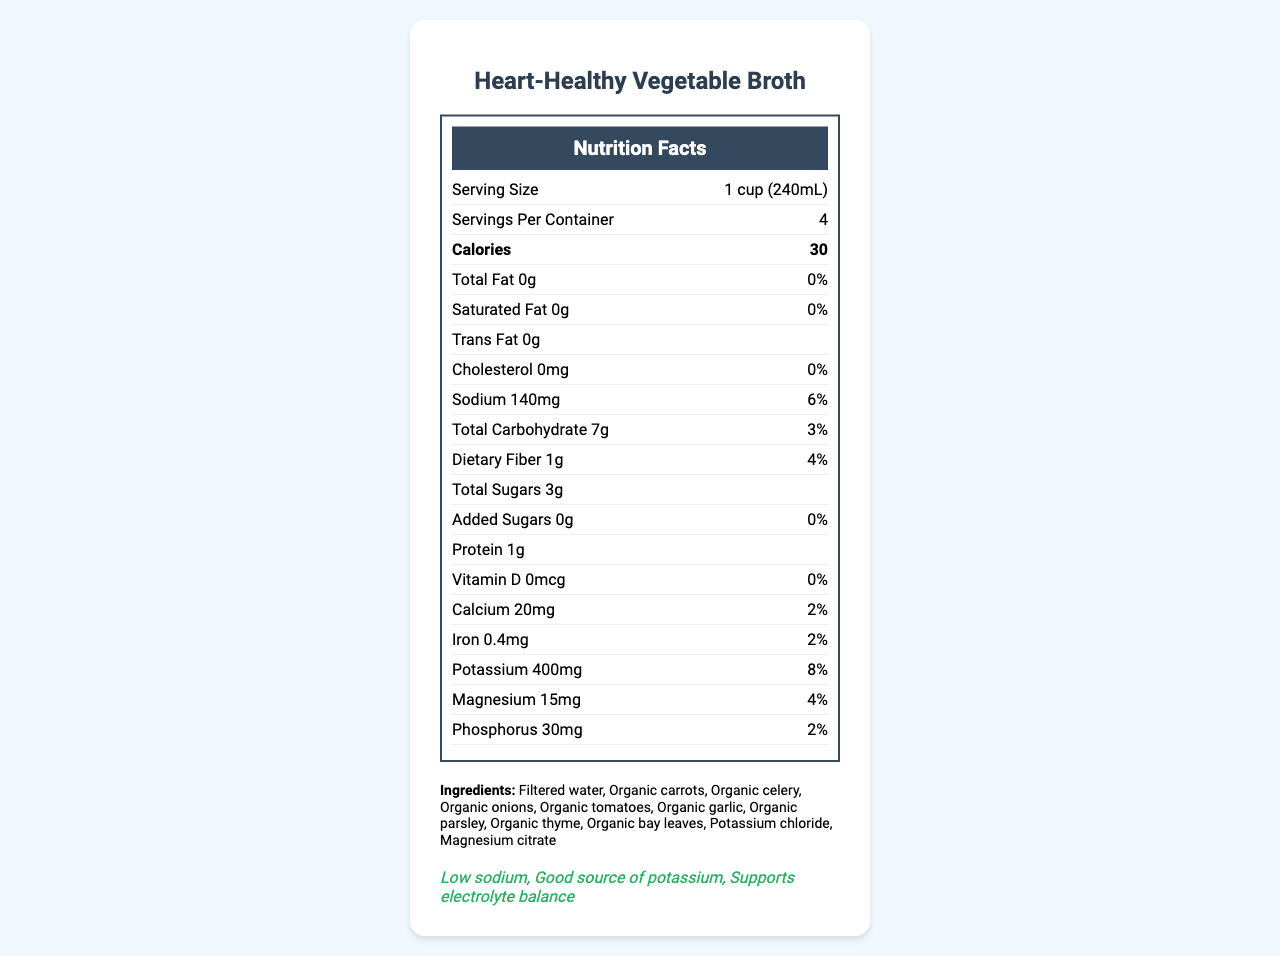what is the serving size of the Heart-Healthy Vegetable Broth? The serving size is clearly stated as "1 cup (240mL)" in the document.
Answer: 1 cup (240mL) how many calories are in one serving of the broth? According to the nutrition label, there are 30 calories in one serving of the broth.
Answer: 30 how much sodium is in one serving? The sodium content for one serving is listed as 140mg on the document.
Answer: 140mg what is the daily value percentage of potassium per serving? The daily value for potassium per serving is shown as 8%.
Answer: 8% what are two of the health claims made on this product? The health claims section mentions "Low sodium" and "Good source of potassium."
Answer: Low sodium and Good source of potassium which ingredient is listed first? The ingredients section lists "Filtered water" as the first ingredient.
Answer: Filtered water what is the daily value percentage of dietary fiber in this broth? The daily value percentage for dietary fiber is listed as 4% on the nutrition label.
Answer: 4% how much iron does one serving provide? The document states that one serving provides 0.4mg of iron.
Answer: 0.4mg is this product high in saturated fat? The saturated fat content is 0g, 0% Daily Value, indicating that it is not high in saturated fat.
Answer: No what is the manufacturer of this product? The manufacturer is stated as NutriBalance Foods, Inc.
Answer: NutriBalance Foods, Inc. how much added sugar is there in a serving of this broth? The document shows that there is no added sugar in a serving of this broth.
Answer: 0g which of the following electrolytes is listed on the nutrition label? A. Sodium B. Potassium C. Magnesium D. All of the above Sodium, potassium, and magnesium are all listed on the nutrition label.
Answer: D. All of the above what is the daily value percentage of calcium for one serving? A. 0% B. 2% C. 4% D. 6% The document lists the daily value percentage for calcium as 2%.
Answer: B. 2% does the nutritional label include vitamin C information? There is no information about vitamin C on the nutrition label in the document.
Answer: No summarize the main idea of the document. The document provides comprehensive nutritional information, ingredients, health claims, and manufacturer details of the Heart-Healthy Vegetable Broth. It highlights its low sodium content and good source of electrolytes.
Answer: The Heart-Healthy Vegetable Broth is a low-calorie, low-sodium product that contains various electrolytes such as potassium and magnesium. It is produced by NutriBalance Foods, Inc. and offers nutritional benefits like low total fat, zero trans fat, and additional minerals such as calcium and iron. how many organic ingredients are listed? The document does not specify the total number of organic ingredients; it simply lists some ingredients as organic.
Answer: Cannot be determined what is the total amount of carbohydrates per serving? The total carbohydrate content per serving is listed as 7g in the document.
Answer: 7g 